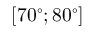Convert formula to latex. <formula><loc_0><loc_0><loc_500><loc_500>[ 7 0 ^ { \circ } ; 8 0 ^ { \circ } ]</formula> 